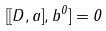<formula> <loc_0><loc_0><loc_500><loc_500>[ [ D , a ] , b ^ { 0 } ] = 0</formula> 